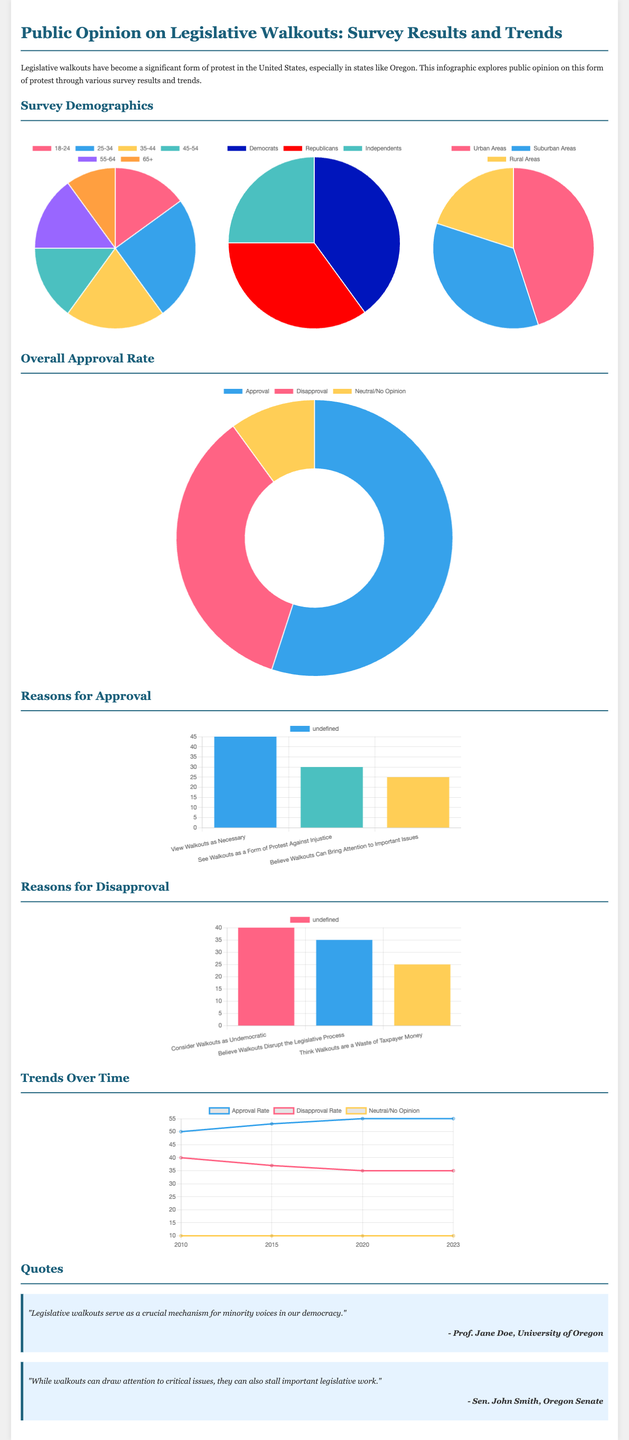What is the overall approval rate for legislative walkouts? The overall approval rate is indicated in the doughnut chart, which shows that 55% approve of legislative walkouts.
Answer: 55% What percentage of survey respondents are Democrats? The political affiliation chart shows that 40% of respondents identify as Democrats.
Answer: 40% Which age group has the lowest percentage of respondents? The age distribution pie chart indicates that the 65+ age group has the lowest percentage at 10%.
Answer: 10% What is the main reason for approving walkouts according to respondents? The bar chart for reasons for approval shows that viewing walkouts as necessary is the predominant reason, at 45%.
Answer: View walkouts as necessary What is the disapproval percentage for legislative walkouts? The overall approval rate chart indicates that 35% of respondents disapprove of legislative walkouts.
Answer: 35% In what year was the approval rate first recorded at 50%? The trends over time line chart indicates that the approval rate was first recorded at 50% in 2010.
Answer: 2010 What is the percentage of respondents in urban areas? The geographical spread chart shows that 45% of respondents live in urban areas.
Answer: 45% Which reason for disapproval has the lowest percentage? The reasons for disapproval bar chart shows that thinking walkouts are a waste of taxpayer money has the lowest percentage at 25%.
Answer: Think walkouts are a waste of taxpayer money What is the primary visual representation method used for the approval reasons? The approval reasons are represented using a bar chart, which helps to compare the different reasons easily.
Answer: Bar chart 